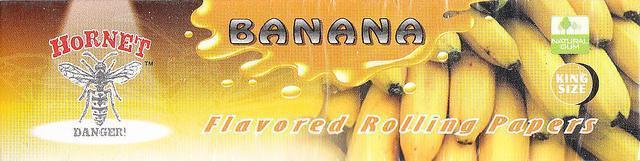How many bananas can you see?
Give a very brief answer. 8. 